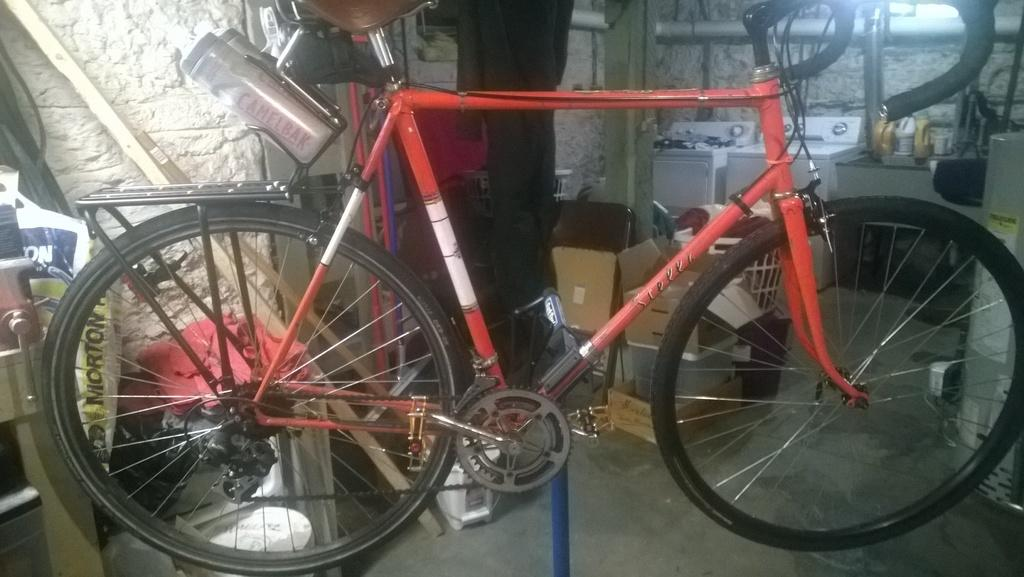What type of bicycle is in the image? There is a red bicycle in the image. What is the bicycle placed on? The bicycle is placed on an object. What can be seen in the background of the image? There are wooden boxes and two washing machines in the background of the image. Are there any other objects present in the background? Yes, there are other objects present in the background of the image. What type of ring can be seen in the wilderness in the image? There is no ring or wilderness present in the image; it features a red bicycle and objects in the background. 